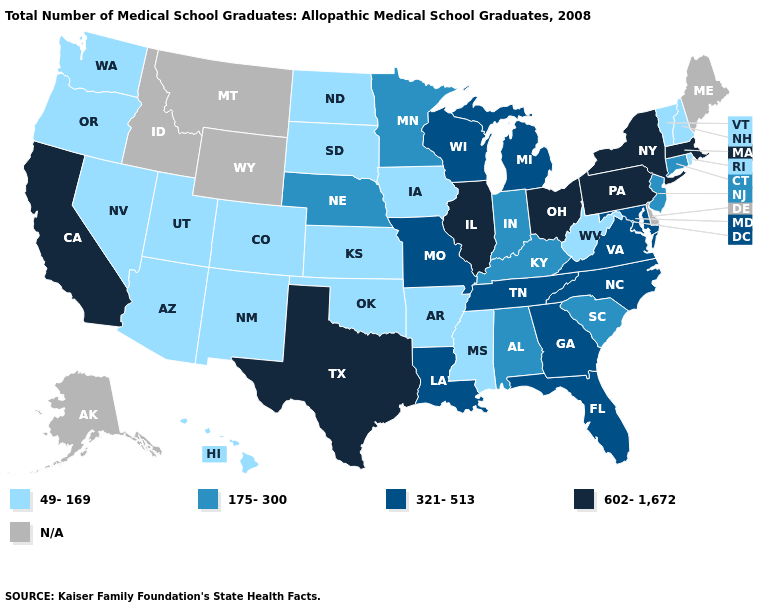Name the states that have a value in the range 602-1,672?
Give a very brief answer. California, Illinois, Massachusetts, New York, Ohio, Pennsylvania, Texas. Does North Dakota have the lowest value in the MidWest?
Short answer required. Yes. Is the legend a continuous bar?
Give a very brief answer. No. Name the states that have a value in the range N/A?
Concise answer only. Alaska, Delaware, Idaho, Maine, Montana, Wyoming. Does Virginia have the lowest value in the USA?
Be succinct. No. Name the states that have a value in the range 49-169?
Give a very brief answer. Arizona, Arkansas, Colorado, Hawaii, Iowa, Kansas, Mississippi, Nevada, New Hampshire, New Mexico, North Dakota, Oklahoma, Oregon, Rhode Island, South Dakota, Utah, Vermont, Washington, West Virginia. Does California have the lowest value in the West?
Concise answer only. No. Name the states that have a value in the range 321-513?
Quick response, please. Florida, Georgia, Louisiana, Maryland, Michigan, Missouri, North Carolina, Tennessee, Virginia, Wisconsin. Does the map have missing data?
Answer briefly. Yes. What is the value of Montana?
Give a very brief answer. N/A. What is the value of New Mexico?
Quick response, please. 49-169. Name the states that have a value in the range 321-513?
Short answer required. Florida, Georgia, Louisiana, Maryland, Michigan, Missouri, North Carolina, Tennessee, Virginia, Wisconsin. Which states have the lowest value in the USA?
Be succinct. Arizona, Arkansas, Colorado, Hawaii, Iowa, Kansas, Mississippi, Nevada, New Hampshire, New Mexico, North Dakota, Oklahoma, Oregon, Rhode Island, South Dakota, Utah, Vermont, Washington, West Virginia. What is the highest value in states that border Maryland?
Be succinct. 602-1,672. 